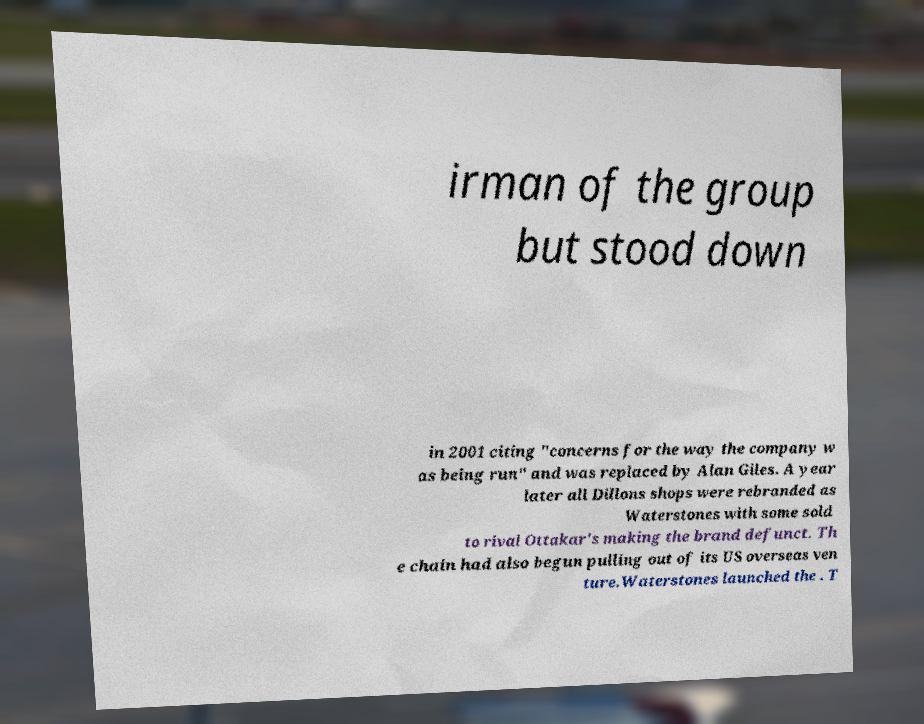Could you assist in decoding the text presented in this image and type it out clearly? irman of the group but stood down in 2001 citing "concerns for the way the company w as being run" and was replaced by Alan Giles. A year later all Dillons shops were rebranded as Waterstones with some sold to rival Ottakar's making the brand defunct. Th e chain had also begun pulling out of its US overseas ven ture.Waterstones launched the . T 